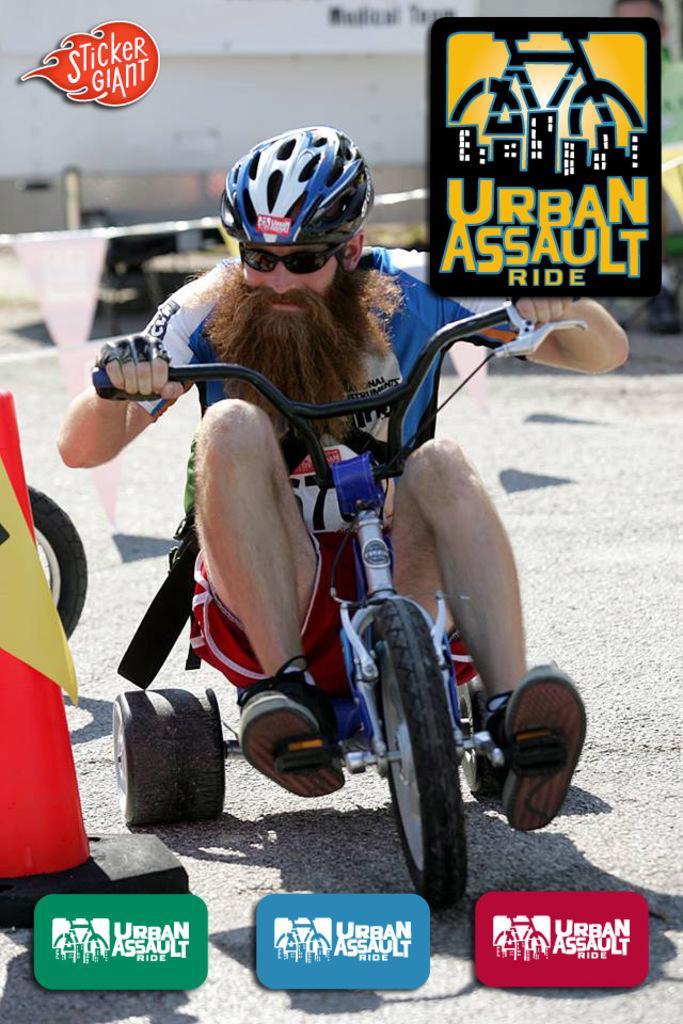In one or two sentences, can you explain what this image depicts? In the middle of the image, there is a person wearing a helmet and sunglasses and a riding a vehicle on the road. On the bottom left, there is a watermark. On the bottom right, there is a watermark. Beside this watermark, there is another watermark. On the top left, there is a watermark. On the top right, there is a watermark. On the left side, there is a pole. In the background, there is a white wall. 